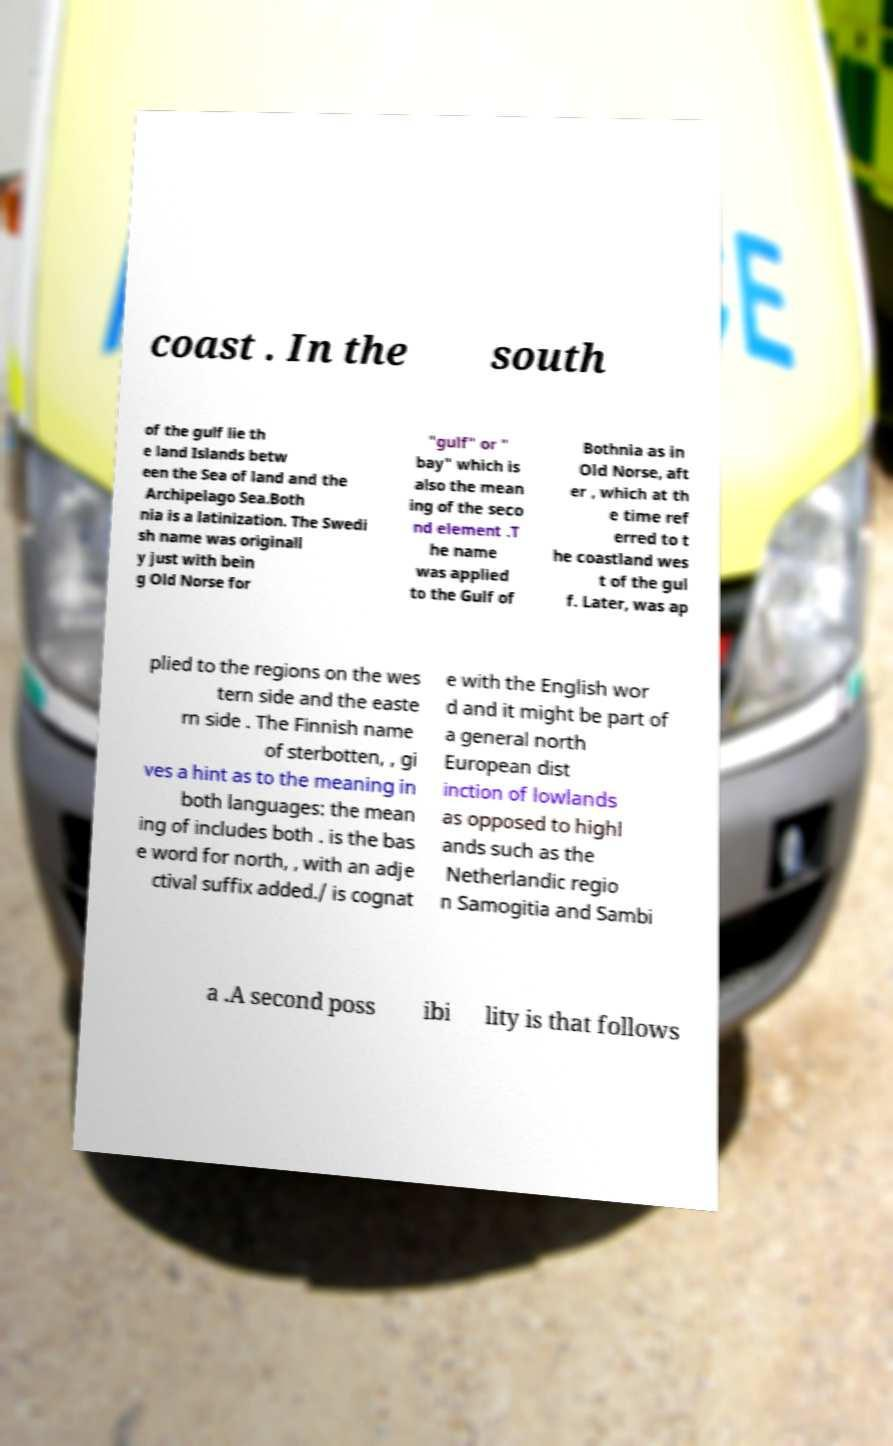Please identify and transcribe the text found in this image. coast . In the south of the gulf lie th e land Islands betw een the Sea of land and the Archipelago Sea.Both nia is a latinization. The Swedi sh name was originall y just with bein g Old Norse for "gulf" or " bay" which is also the mean ing of the seco nd element .T he name was applied to the Gulf of Bothnia as in Old Norse, aft er , which at th e time ref erred to t he coastland wes t of the gul f. Later, was ap plied to the regions on the wes tern side and the easte rn side . The Finnish name of sterbotten, , gi ves a hint as to the meaning in both languages: the mean ing of includes both . is the bas e word for north, , with an adje ctival suffix added./ is cognat e with the English wor d and it might be part of a general north European dist inction of lowlands as opposed to highl ands such as the Netherlandic regio n Samogitia and Sambi a .A second poss ibi lity is that follows 